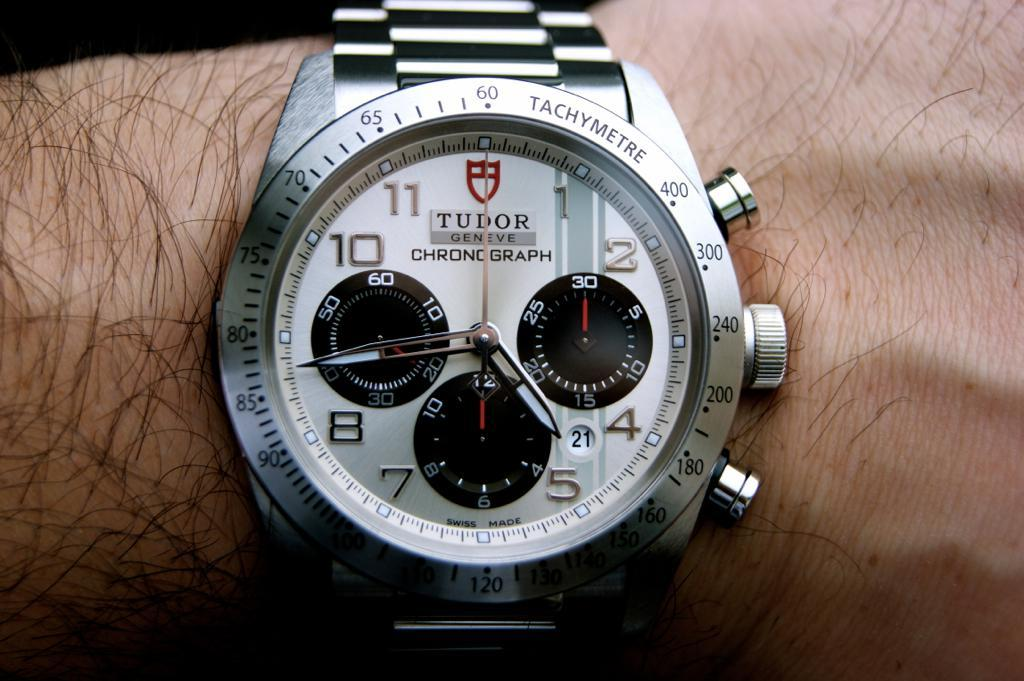Provide a one-sentence caption for the provided image. A man is wearing a silver watch that says Tudor Geneve. 